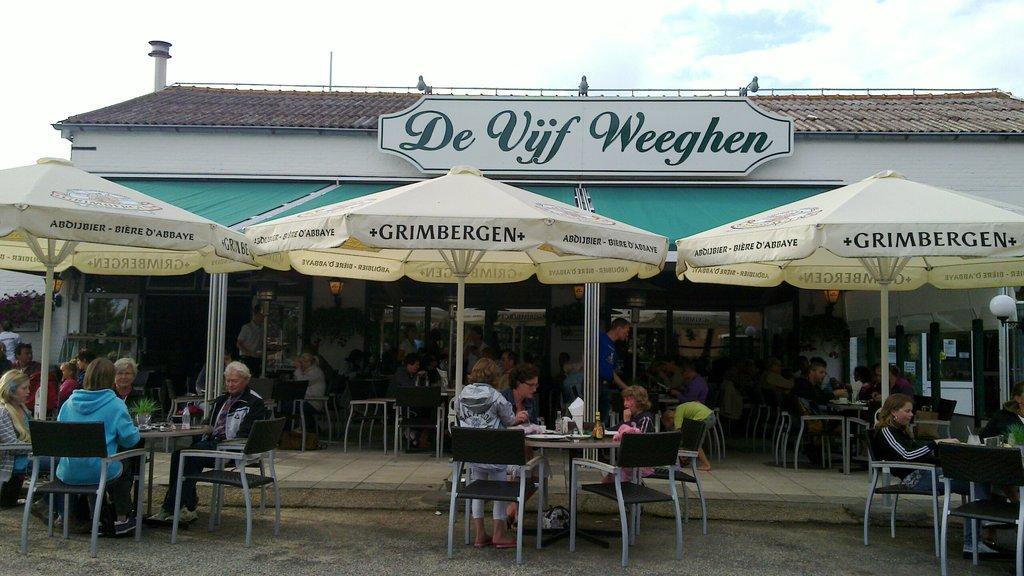In one or two sentences, can you explain what this image depicts? People are sitting on chairs. In-front of them there are tables. On these tables there are bottles and things. These are umbrellas. Here we can see lights and hoarding.  